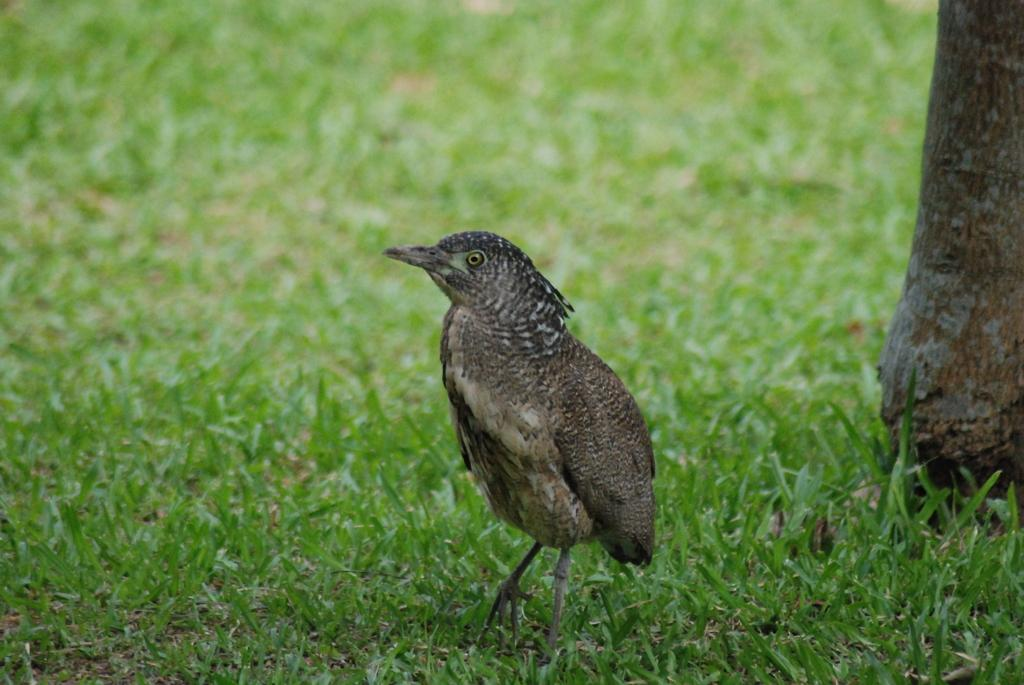What type of animal can be seen in the image? There is a bird in the image. Where is the bird located in the image? The bird is standing on the grass. Can you describe the background of the image? The background of the image is blurred. What type of peace is the bird promoting in the image? The image does not depict the bird promoting any type of peace; it simply shows the bird standing on the grass. 